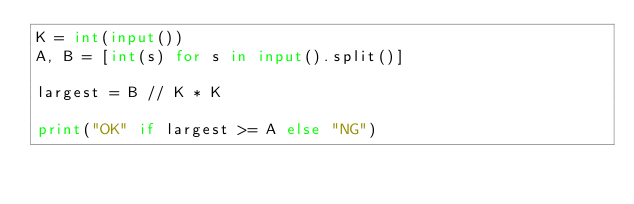Convert code to text. <code><loc_0><loc_0><loc_500><loc_500><_Python_>K = int(input())
A, B = [int(s) for s in input().split()]
 
largest = B // K * K
 
print("OK" if largest >= A else "NG")</code> 